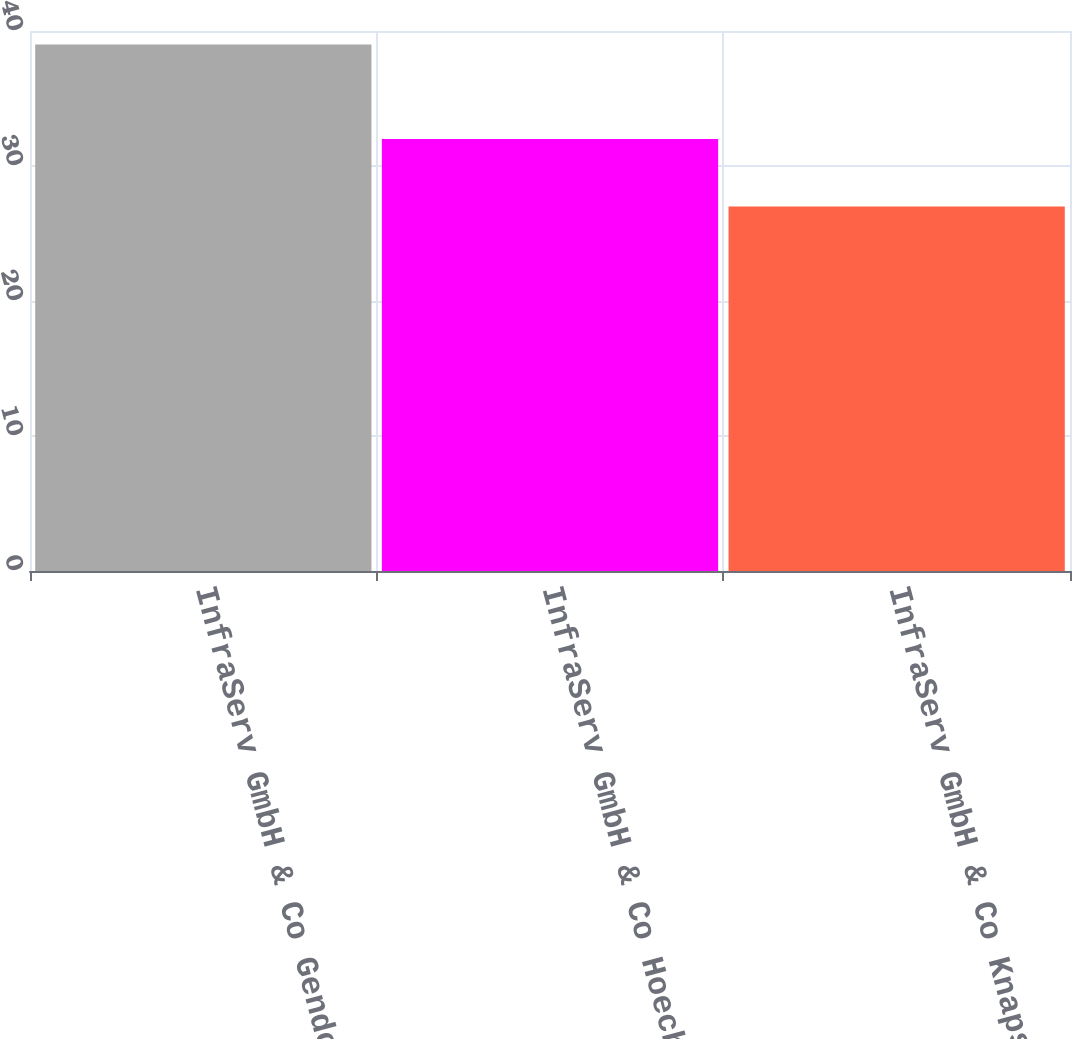Convert chart to OTSL. <chart><loc_0><loc_0><loc_500><loc_500><bar_chart><fcel>InfraServ GmbH & Co Gendorf KG<fcel>InfraServ GmbH & Co Hoechst KG<fcel>InfraServ GmbH & Co Knapsack<nl><fcel>39<fcel>32<fcel>27<nl></chart> 